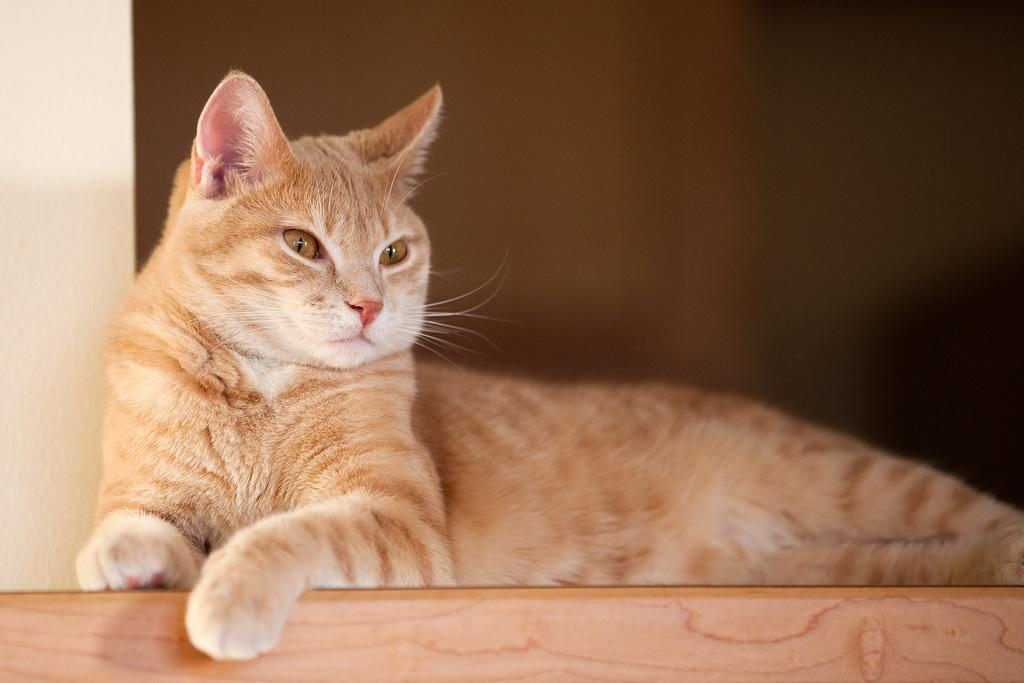What animal can be seen in the image? There is a cat in the image. Where is the cat sitting? The cat is sitting on a wooden block. What other object is present in the image? There is a pillar in the image. What is the color of the pillar? The pillar is white in color. How would you describe the background of the image? The background of the image appears blurry. What type of loaf is the cat holding in the image? There is no loaf present in the image; the cat is sitting on a wooden block. 